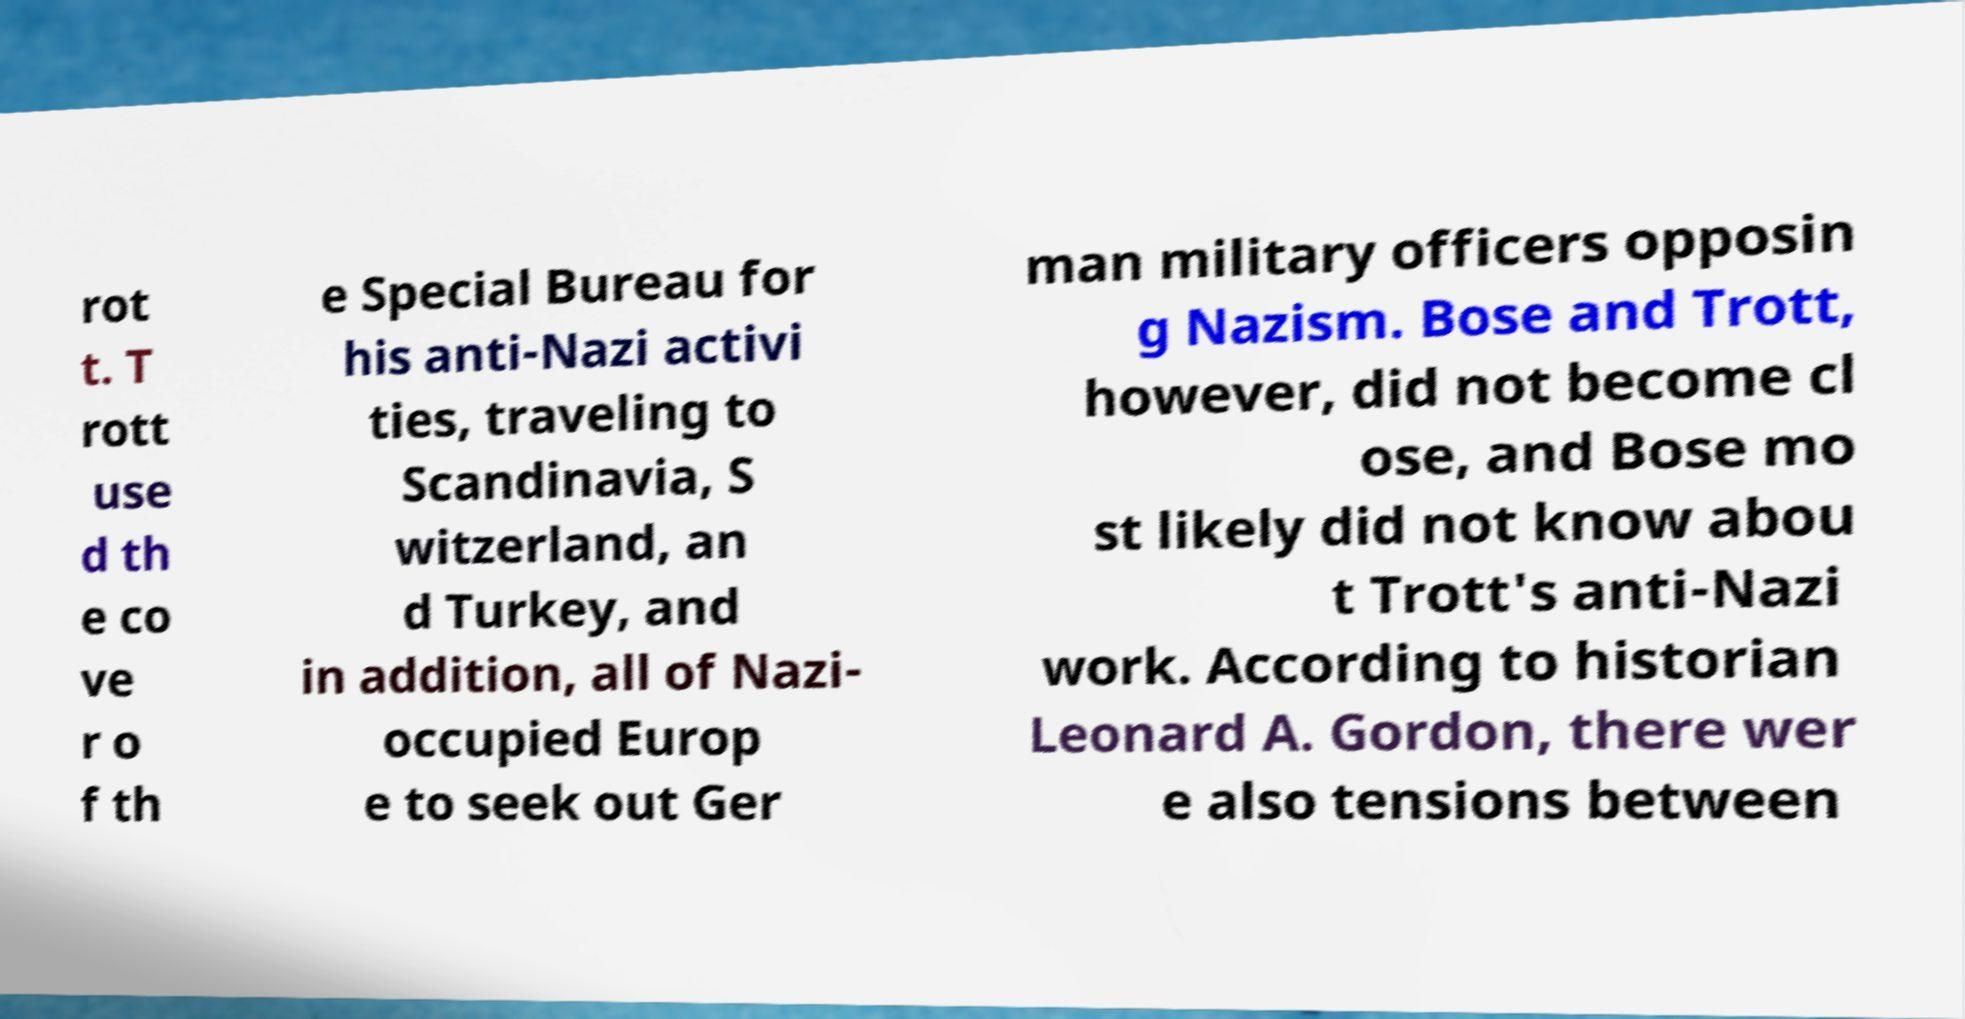Please identify and transcribe the text found in this image. rot t. T rott use d th e co ve r o f th e Special Bureau for his anti-Nazi activi ties, traveling to Scandinavia, S witzerland, an d Turkey, and in addition, all of Nazi- occupied Europ e to seek out Ger man military officers opposin g Nazism. Bose and Trott, however, did not become cl ose, and Bose mo st likely did not know abou t Trott's anti-Nazi work. According to historian Leonard A. Gordon, there wer e also tensions between 